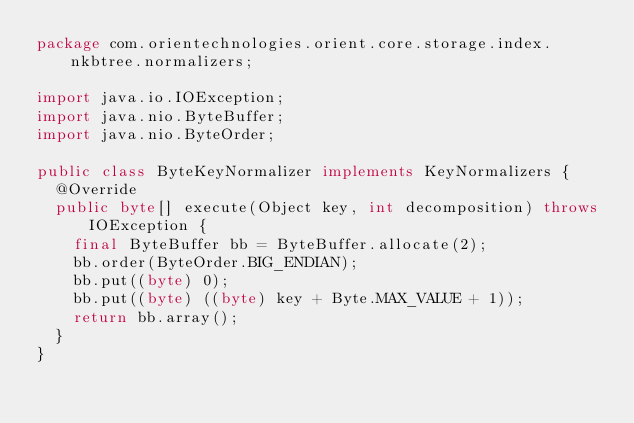Convert code to text. <code><loc_0><loc_0><loc_500><loc_500><_Java_>package com.orientechnologies.orient.core.storage.index.nkbtree.normalizers;

import java.io.IOException;
import java.nio.ByteBuffer;
import java.nio.ByteOrder;

public class ByteKeyNormalizer implements KeyNormalizers {
  @Override
  public byte[] execute(Object key, int decomposition) throws IOException {
    final ByteBuffer bb = ByteBuffer.allocate(2);
    bb.order(ByteOrder.BIG_ENDIAN);
    bb.put((byte) 0);
    bb.put((byte) ((byte) key + Byte.MAX_VALUE + 1));
    return bb.array();
  }
}
</code> 